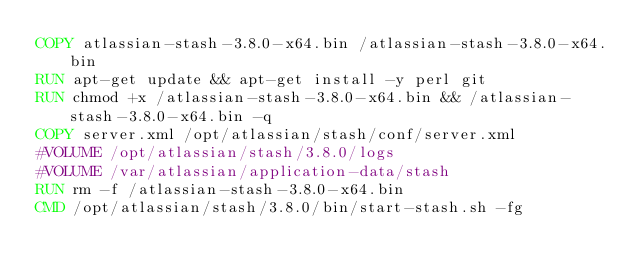Convert code to text. <code><loc_0><loc_0><loc_500><loc_500><_Dockerfile_>COPY atlassian-stash-3.8.0-x64.bin /atlassian-stash-3.8.0-x64.bin
RUN apt-get update && apt-get install -y perl git
RUN chmod +x /atlassian-stash-3.8.0-x64.bin && /atlassian-stash-3.8.0-x64.bin -q
COPY server.xml /opt/atlassian/stash/conf/server.xml
#VOLUME /opt/atlassian/stash/3.8.0/logs
#VOLUME /var/atlassian/application-data/stash
RUN rm -f /atlassian-stash-3.8.0-x64.bin
CMD /opt/atlassian/stash/3.8.0/bin/start-stash.sh -fg
</code> 